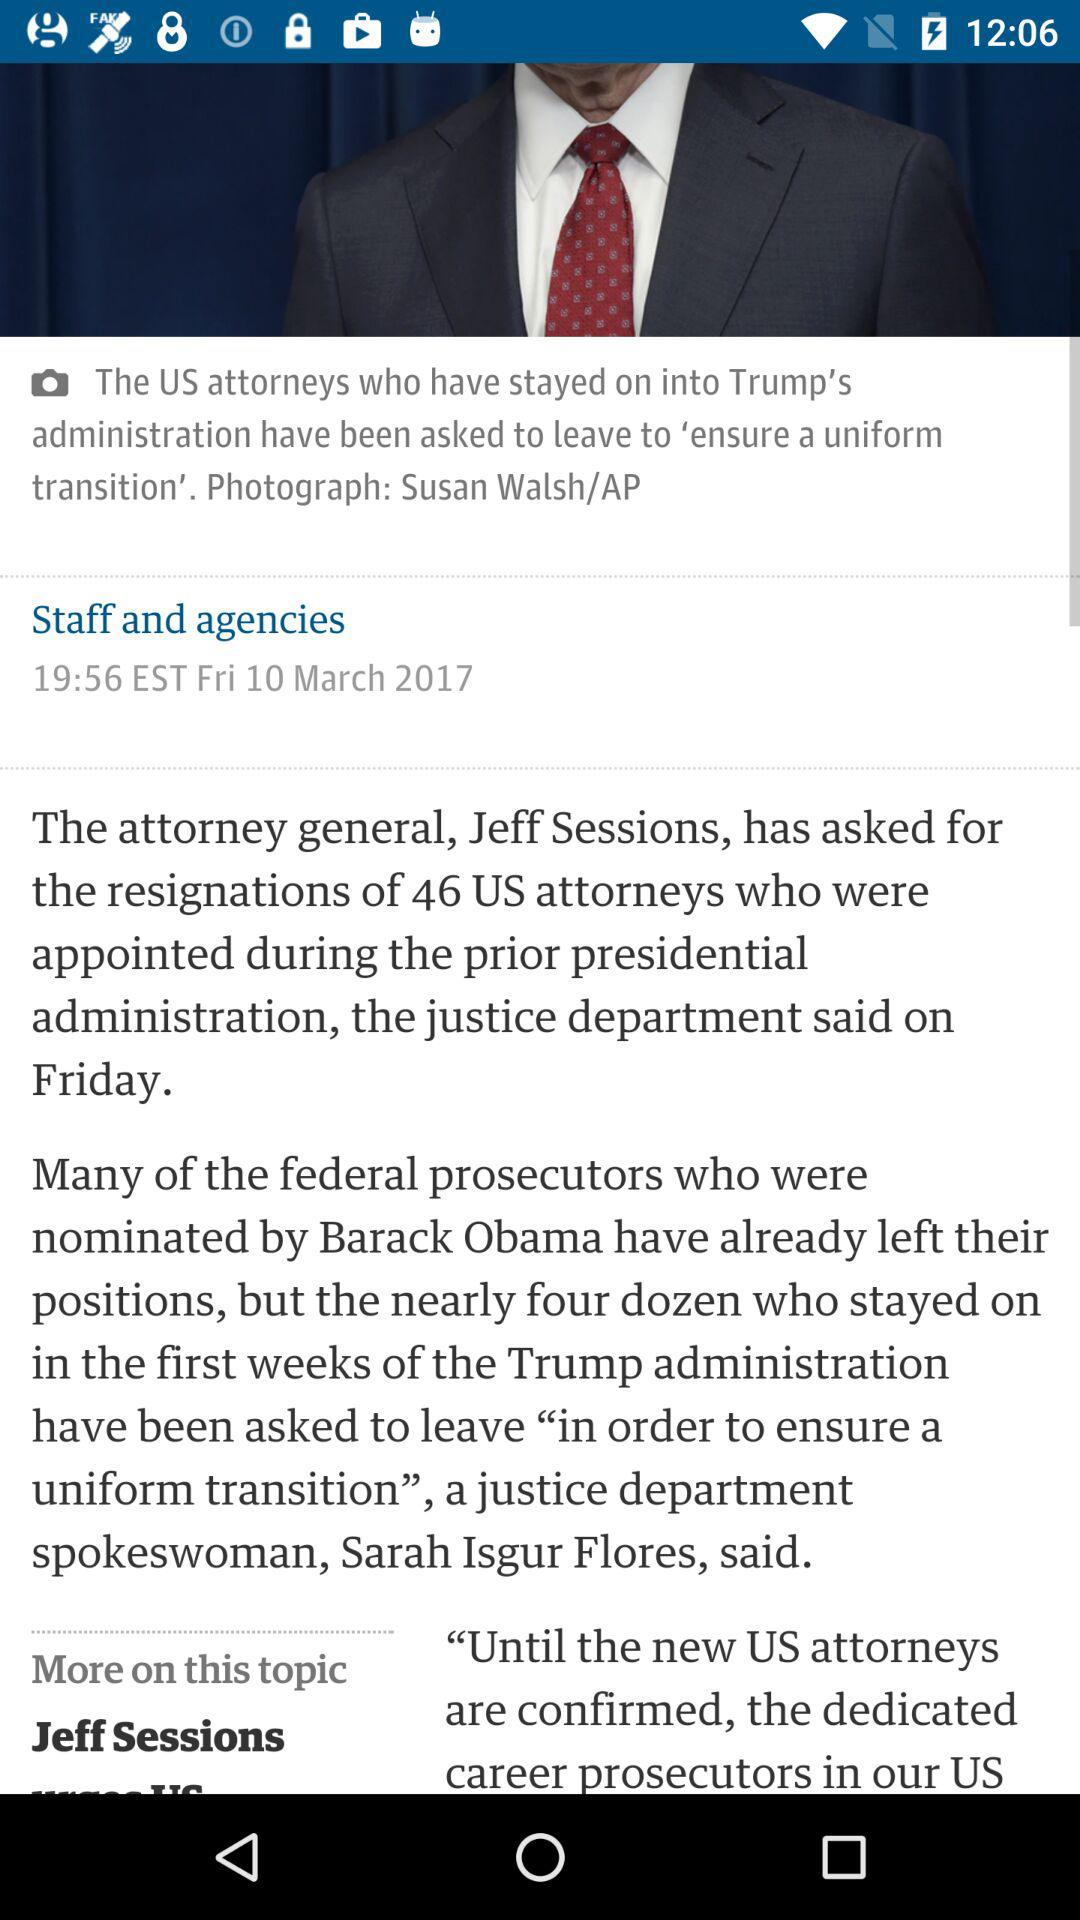How many attorneys were asked to resign?
Answer the question using a single word or phrase. 46 